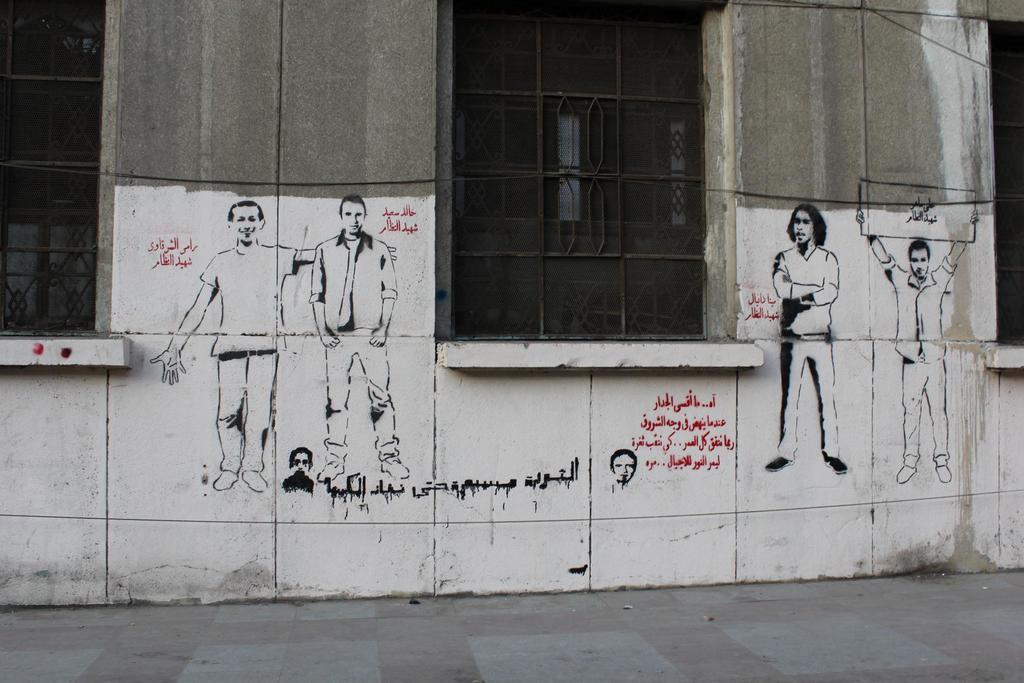How would you summarize this image in a sentence or two? In this picture I can see a wall with windows, there is a painting of people and words on the wall. 